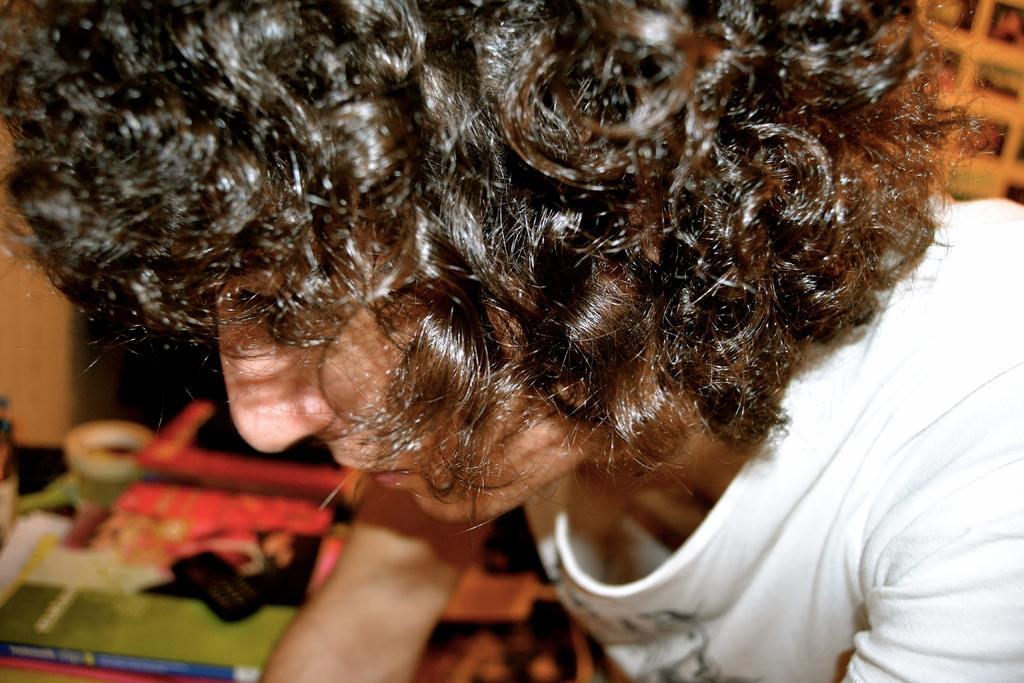Describe this image in one or two sentences. In this image we can see a person. There are few objects at the bottom of the image. 